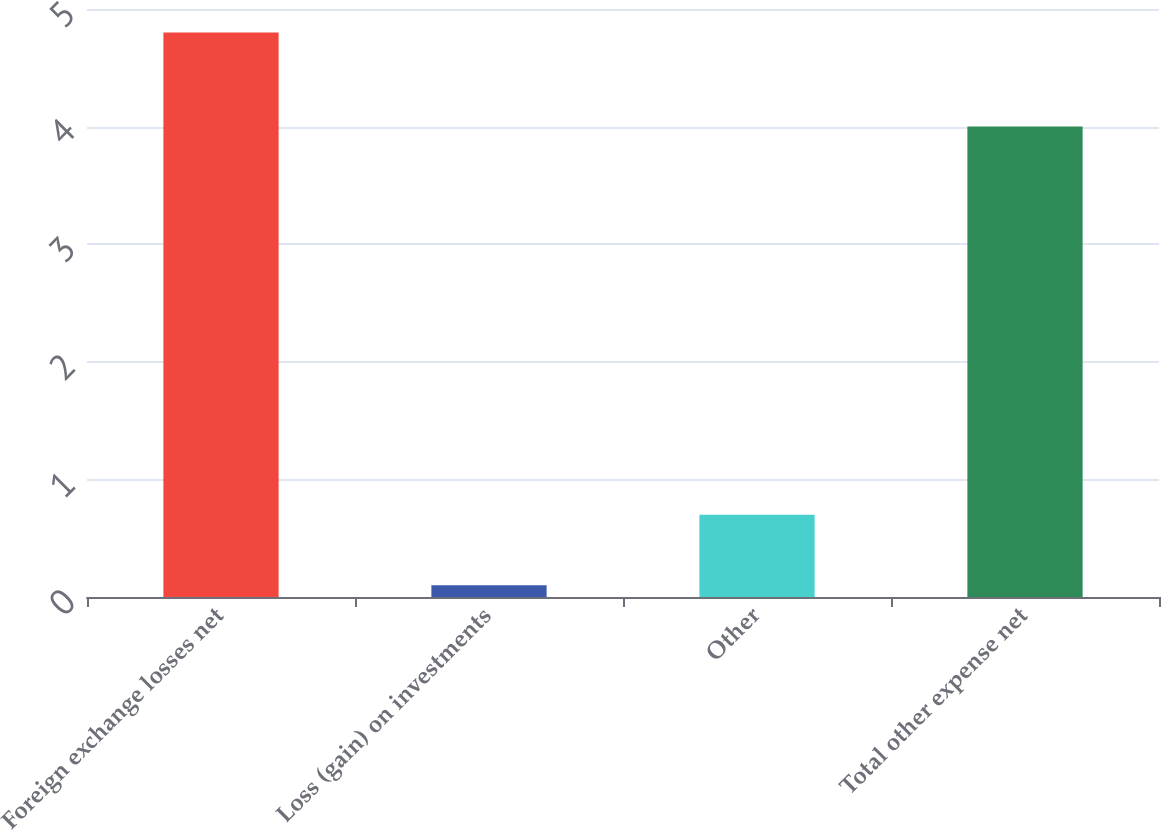Convert chart. <chart><loc_0><loc_0><loc_500><loc_500><bar_chart><fcel>Foreign exchange losses net<fcel>Loss (gain) on investments<fcel>Other<fcel>Total other expense net<nl><fcel>4.8<fcel>0.1<fcel>0.7<fcel>4<nl></chart> 